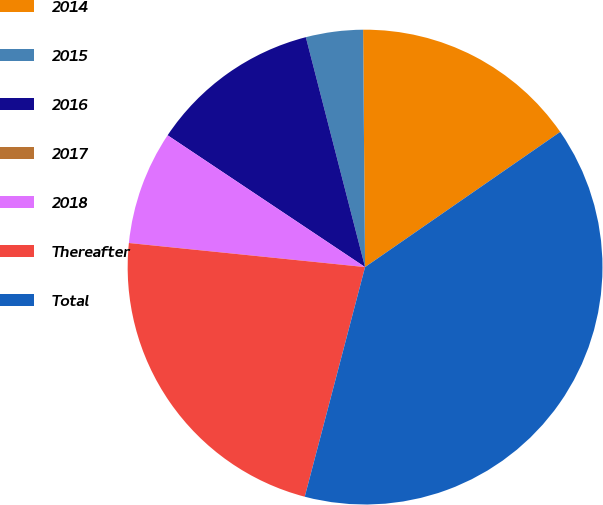Convert chart. <chart><loc_0><loc_0><loc_500><loc_500><pie_chart><fcel>2014<fcel>2015<fcel>2016<fcel>2017<fcel>2018<fcel>Thereafter<fcel>Total<nl><fcel>15.49%<fcel>3.88%<fcel>11.62%<fcel>0.0%<fcel>7.75%<fcel>22.53%<fcel>38.73%<nl></chart> 